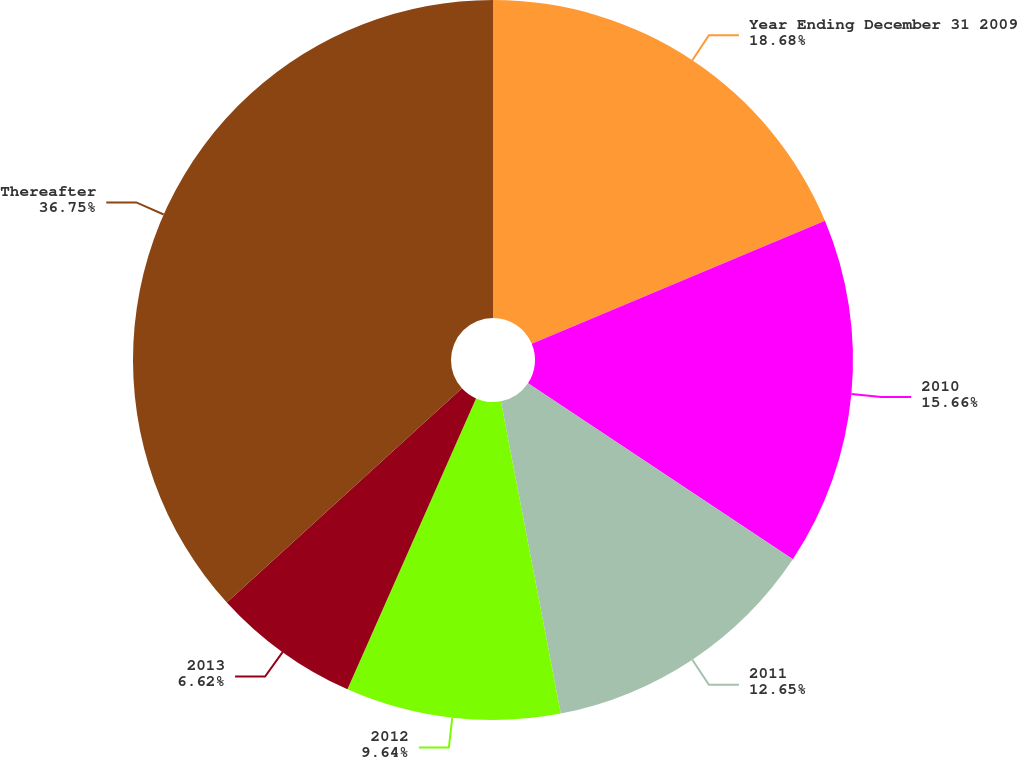<chart> <loc_0><loc_0><loc_500><loc_500><pie_chart><fcel>Year Ending December 31 2009<fcel>2010<fcel>2011<fcel>2012<fcel>2013<fcel>Thereafter<nl><fcel>18.68%<fcel>15.66%<fcel>12.65%<fcel>9.64%<fcel>6.62%<fcel>36.76%<nl></chart> 